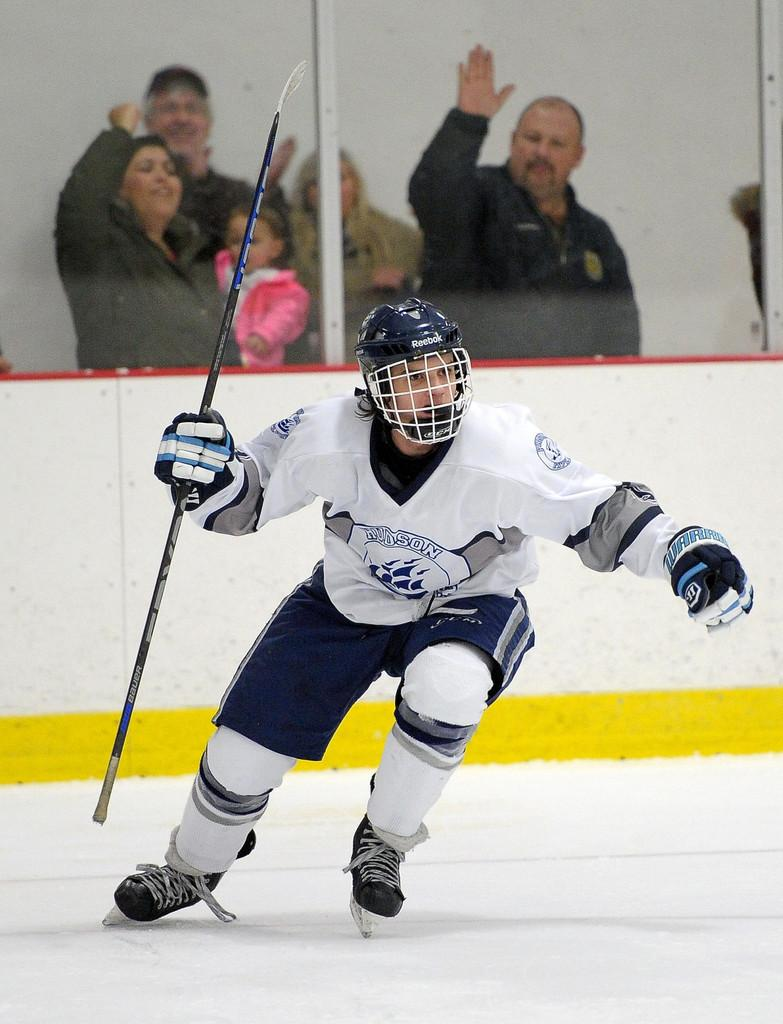What is the person in the image doing? The person is skating on the ice. What object is the person holding while skating? The person is holding a stick. Can you describe the background of the image? There are people standing in the background of the image. How many passengers are visible in the mine in the image? There is no mine or passengers present in the image; it features a person skating on the ice while holding a stick. 